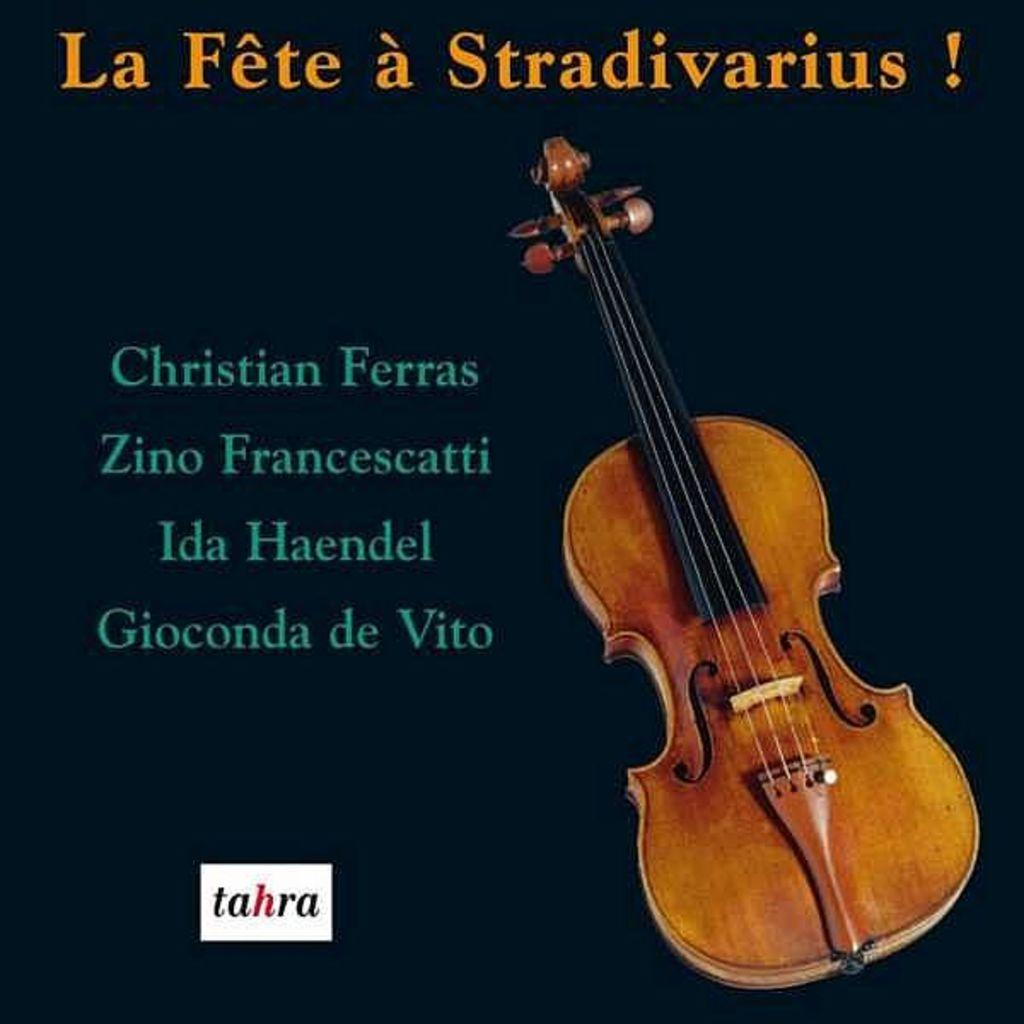What is depicted on the paper print in the image? The paper print features a violin. What else can be seen on the paper print besides the violin? There is written matter on the paper print. What type of shoes can be seen in the advertisement in the image? There is no advertisement or shoes present in the image; it features a paper print with a violin and written matter. 